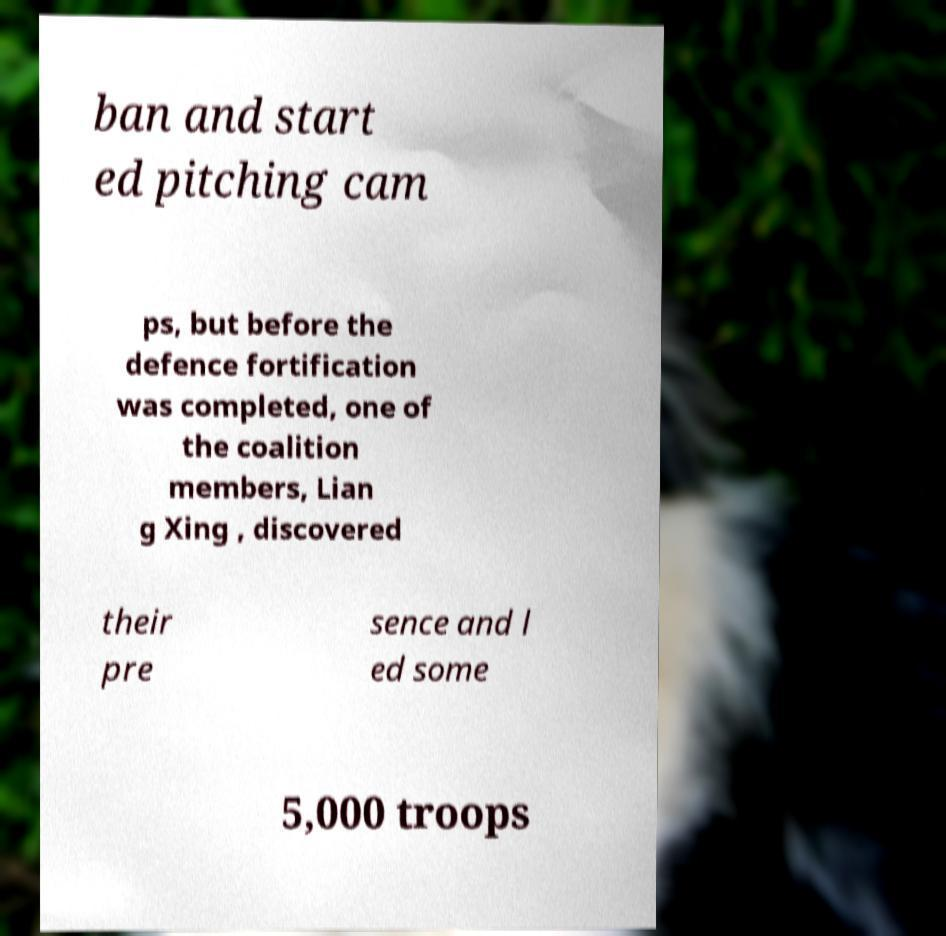Can you accurately transcribe the text from the provided image for me? ban and start ed pitching cam ps, but before the defence fortification was completed, one of the coalition members, Lian g Xing , discovered their pre sence and l ed some 5,000 troops 